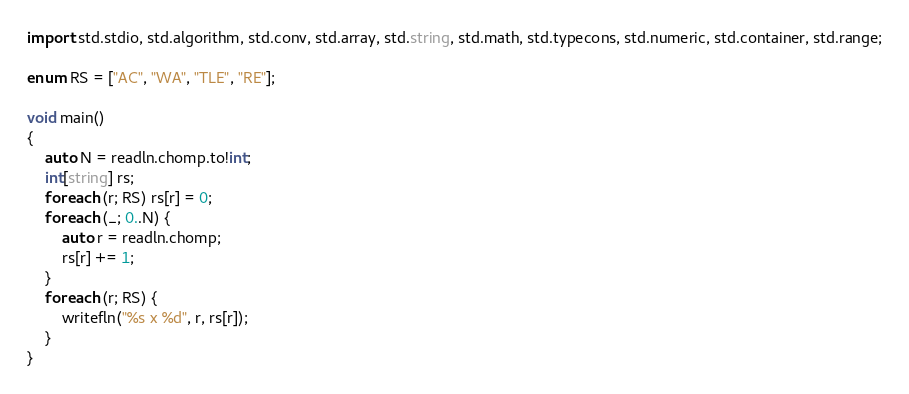<code> <loc_0><loc_0><loc_500><loc_500><_D_>import std.stdio, std.algorithm, std.conv, std.array, std.string, std.math, std.typecons, std.numeric, std.container, std.range;

enum RS = ["AC", "WA", "TLE", "RE"];

void main()
{
    auto N = readln.chomp.to!int;
    int[string] rs;
    foreach (r; RS) rs[r] = 0;
    foreach (_; 0..N) {
        auto r = readln.chomp;
        rs[r] += 1;
    }
    foreach (r; RS) {
        writefln("%s x %d", r, rs[r]);
    }
}</code> 